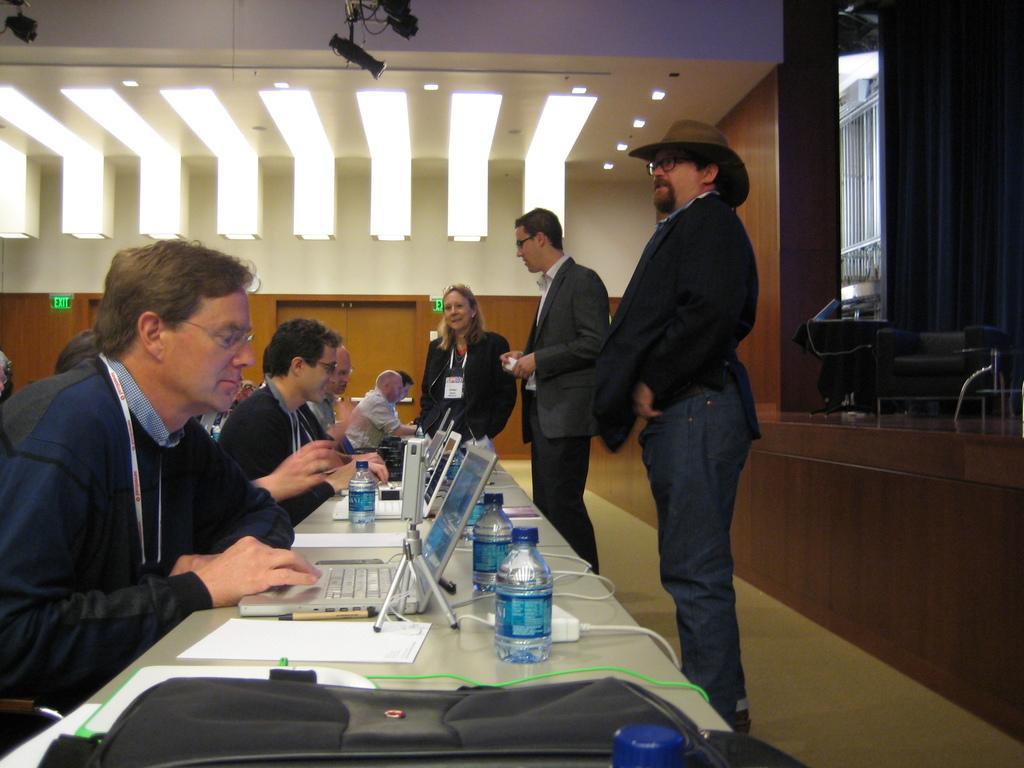How would you summarize this image in a sentence or two? In this image we can see some people, bottles, table, laptops and other objects. In the background of the image there is a wall, lights, wooden objects and other objects. On the right side of the image there are some objects. 